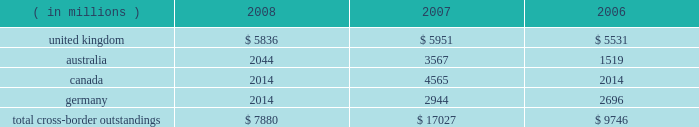Cross-border outstandings cross-border outstandings , as defined by bank regulatory rules , are amounts payable to state street by residents of foreign countries , regardless of the currency in which the claim is denominated , and local country claims in excess of local country obligations .
These cross-border outstandings consist primarily of deposits with banks , loan and lease financing and investment securities .
In addition to credit risk , cross-border outstandings have the risk that , as a result of political or economic conditions in a country , borrowers may be unable to meet their contractual repayment obligations of principal and/or interest when due because of the unavailability of , or restrictions on , foreign exchange needed by borrowers to repay their obligations .
Cross-border outstandings to countries in which we do business which amounted to at least 1% ( 1 % ) of our consolidated total assets were as follows as of december 31: .
The total cross-border outstandings presented in the table represented 5% ( 5 % ) , 12% ( 12 % ) and 9% ( 9 % ) of our consolidated total assets as of december 31 , 2008 , 2007 and 2006 , respectively .
Aggregate cross-border outstandings to countries which totaled between .75% ( .75 % ) and 1% ( 1 % ) of our consolidated total assets at december 31 , 2008 amounted to $ 3.45 billion ( canada and germany ) .
There were no cross-border outstandings to countries which totaled between .75% ( .75 % ) and 1% ( 1 % ) of our consolidated total assets as of december 31 , 2007 .
Aggregate cross-border outstandings to countries which totaled between .75% ( .75 % ) and 1% ( 1 % ) of our consolidated total assets at december 31 , 2006 amounted to $ 1.05 billion ( canada ) .
Capital regulatory and economic capital management both use key metrics evaluated by management to assess whether our actual level of capital is commensurate with our risk profile , is in compliance with all regulatory requirements , and is sufficient to provide us with the financial flexibility to undertake future strategic business initiatives .
Regulatory capital our objective with respect to regulatory capital management is to maintain a strong capital base in order to provide financial flexibility for our business needs , including funding corporate growth and supporting customers 2019 cash management needs , and to provide protection against loss to depositors and creditors .
We strive to maintain an optimal level of capital , commensurate with our risk profile , on which an attractive return to shareholders will be realized over both the short and long term , while protecting our obligations to depositors and creditors and satisfying regulatory requirements .
Our capital management process focuses on our risk exposures , our capital position relative to our peers , regulatory capital requirements and the evaluations of the major independent credit rating agencies that assign ratings to our public debt .
Our capital committee , working in conjunction with our asset and liability committee , referred to as alco , oversees the management of regulatory capital , and is responsible for ensuring capital adequacy with respect to regulatory requirements , internal targets and the expectations of the major independent credit rating agencies .
The primary regulator of both state street and state street bank for regulatory capital purposes is the federal reserve .
Both state street and state street bank are subject to the minimum capital requirements established by the federal reserve and defined in the federal deposit insurance corporation improvement act .
What are the consolidated total assets as of december 31 , 2008? 
Computations: (7880 / 5%)
Answer: 157600.0. 